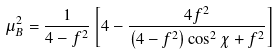<formula> <loc_0><loc_0><loc_500><loc_500>\mu _ { B } ^ { 2 } = \frac { 1 } { 4 - f ^ { 2 } } \left [ 4 - \frac { 4 f ^ { 2 } } { \left ( 4 - f ^ { 2 } \right ) \cos ^ { 2 } \chi + f ^ { 2 } } \right ]</formula> 